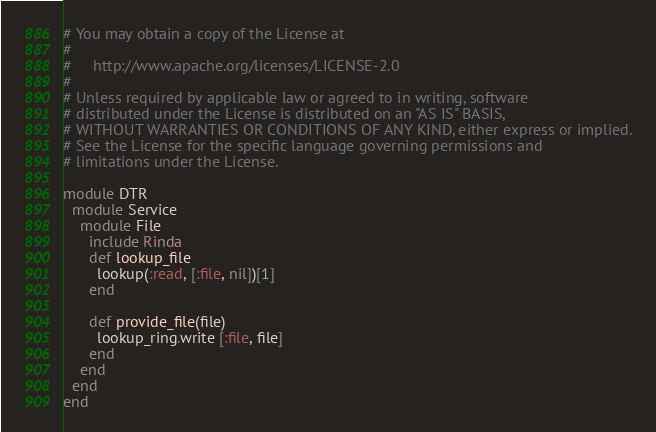Convert code to text. <code><loc_0><loc_0><loc_500><loc_500><_Ruby_># You may obtain a copy of the License at
# 
#     http://www.apache.org/licenses/LICENSE-2.0
# 
# Unless required by applicable law or agreed to in writing, software
# distributed under the License is distributed on an "AS IS" BASIS,
# WITHOUT WARRANTIES OR CONDITIONS OF ANY KIND, either express or implied.
# See the License for the specific language governing permissions and
# limitations under the License.

module DTR
  module Service
    module File
      include Rinda
      def lookup_file
        lookup(:read, [:file, nil])[1]
      end

      def provide_file(file)
        lookup_ring.write [:file, file]
      end
    end
  end
end
</code> 